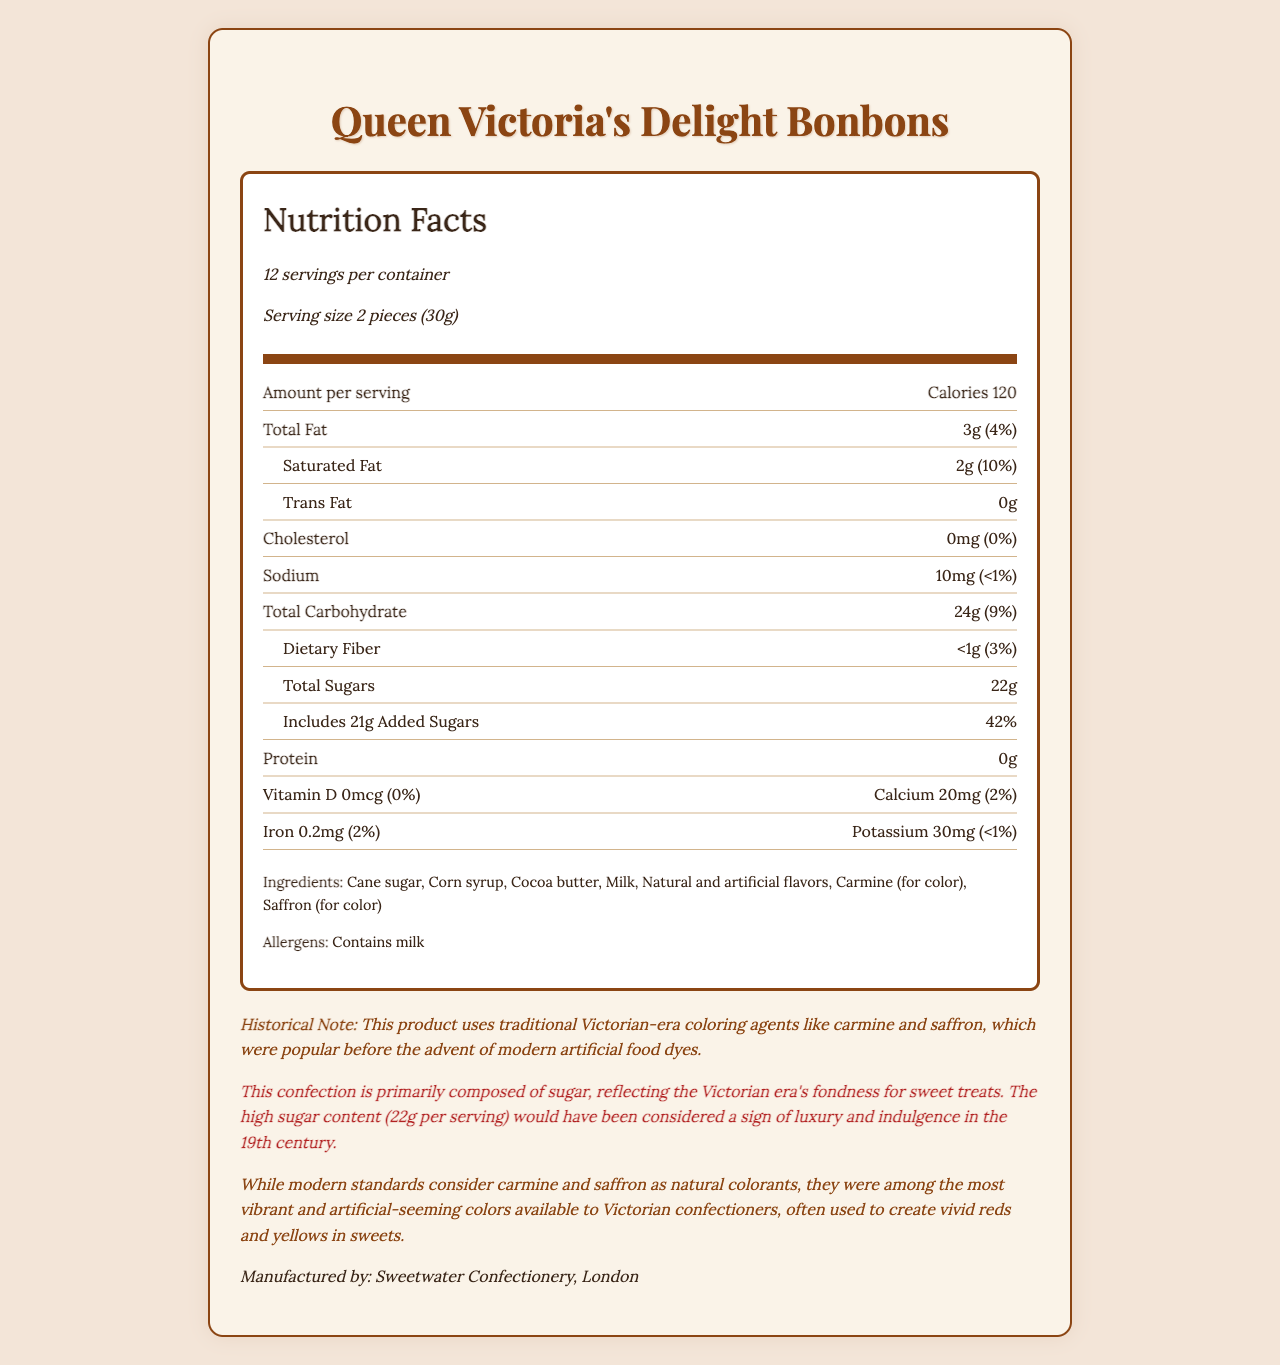what is the serving size? The serving size is explicitly mentioned in the document as "2 pieces (30g)".
Answer: 2 pieces (30g) how many servings are there per container? The document states that there are 12 servings per container.
Answer: 12 how many calories are in one serving? The document shows the amount of calories per serving as 120.
Answer: 120 what is the amount of total sugars per serving? The document lists the total sugars per serving as 22g.
Answer: 22g how much added sugars are in one serving, and what percentage of the daily value does it represent? The document states that one serving includes 21g of added sugars, which represents 42% of the daily value.
Answer: 21g, 42% which of the following is used as a colorant in the bonbons? A. Beetroot B. Carmine C. Spirulina The document lists carmine as one of the ingredients used for coloring.
Answer: B. Carmine how much calcium per serving do the Queen Victoria's Delight Bonbons contain? A. 2mg B. 20mg C. 200mg The document specifies that each serving contains 20mg of calcium.
Answer: B. 20mg are there any trans fats in the bonbons? The document lists trans fat as 0g.
Answer: No is there any cholesterol in Queen Victoria's Delight Bonbons? The document states the amount of cholesterol as 0mg.
Answer: No describe the main idea of the document. The document includes comprehensive nutrition facts, ingredient list, allergen information, and historical context of the product, emphasizing its high sugar content and the use of vivid natural colorants like carmine and saffron.
Answer: The document provides detailed nutritional information about Queen Victoria's Delight Bonbons. It includes serving size, number of servings per container, and nutritional content per serving such as calories, fats, carbohydrates, sugars, proteins, and vitamins. Additionally, it highlights the confection's high sugar content and the use of traditional Victorian-era natural coloring agents. what is the historical significance of the colors used in the bonbons? The document notes that carmine and saffron were common coloring agents in Victorian sweets, reflecting the period's preference for vibrant hues before synthetic dyes.
Answer: Colors like carmine and saffron were popular in the Victorian era before modern artificial dyes, giving a vibrant yet natural appearance to sweets. who manufactures these bonbons? The manufacturer is mentioned at the bottom of the document as Sweetwater Confectionery, London.
Answer: Sweetwater Confectionery, London how much sodium is in each serving? The document lists the sodium content per serving as 10mg.
Answer: 10mg can you determine the retail price of the bonbons from the document? The document does not contain any information regarding the retail price of the bonbons.
Answer: Cannot be determined what allergens are present in Queen Victoria's Delight Bonbons? The document states that the bonbons contain milk, listed under allergens.
Answer: Milk how does the document emphasize the sugar content? The sugar content is highlighted in the document, noting that it reflects the Victorian era’s preference for sugary confections and is seen as a sign of luxury and indulgence.
Answer: The confection is primarily composed of sugar, with 22g of total sugars per serving, reflecting the Victorian era's fondness for sweet treats. 